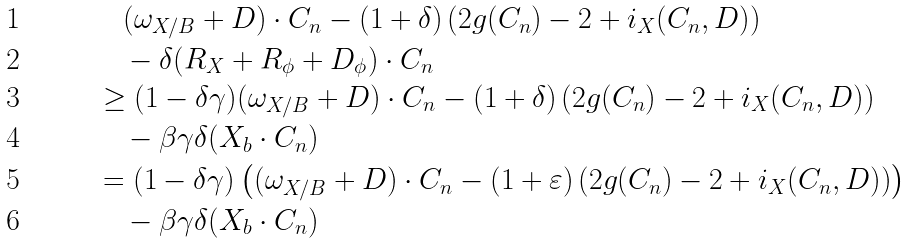Convert formula to latex. <formula><loc_0><loc_0><loc_500><loc_500>& \quad ( \omega _ { X / B } + D ) \cdot C _ { n } - ( 1 + \delta ) \left ( 2 g ( C _ { n } ) - 2 + i _ { X } ( C _ { n } , D ) \right ) \\ & \quad - \delta ( R _ { X } + R _ { \phi } + D _ { \phi } ) \cdot C _ { n } \\ & \geq ( 1 - \delta \gamma ) ( \omega _ { X / B } + D ) \cdot C _ { n } - ( 1 + \delta ) \left ( 2 g ( C _ { n } ) - 2 + i _ { X } ( C _ { n } , D ) \right ) \\ & \quad - \beta \gamma \delta ( X _ { b } \cdot C _ { n } ) \\ & = ( 1 - \delta \gamma ) \left ( ( \omega _ { X / B } + D ) \cdot C _ { n } - ( 1 + \varepsilon ) \left ( 2 g ( C _ { n } ) - 2 + i _ { X } ( C _ { n } , D ) \right ) \right ) \\ & \quad - \beta \gamma \delta ( X _ { b } \cdot C _ { n } )</formula> 